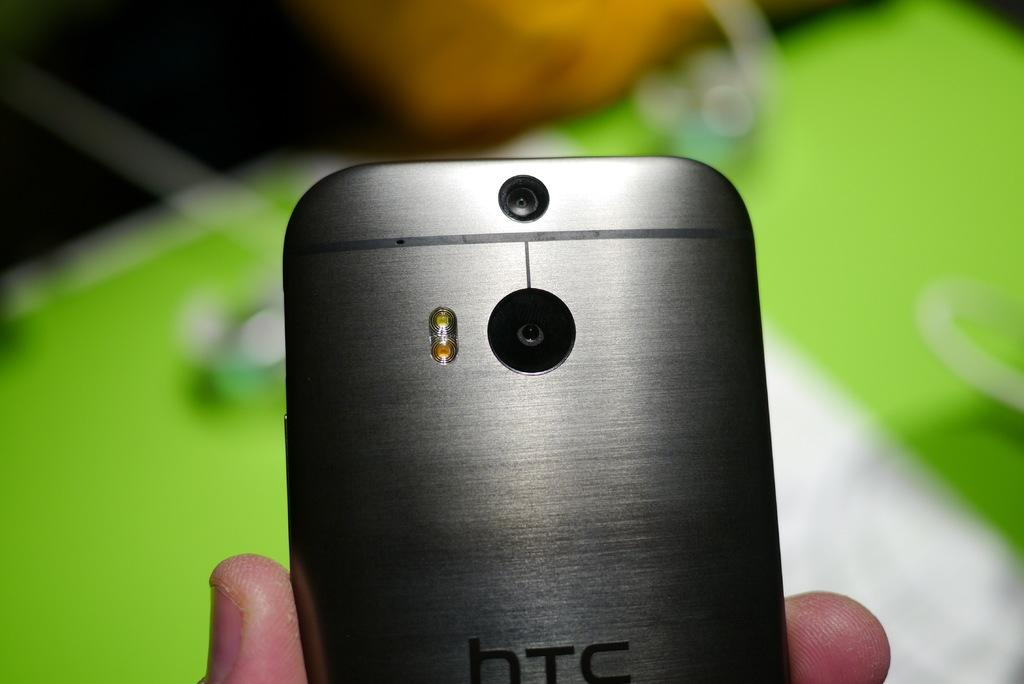Provide a one-sentence caption for the provided image. Silver htc phone with a black camera on the back. 